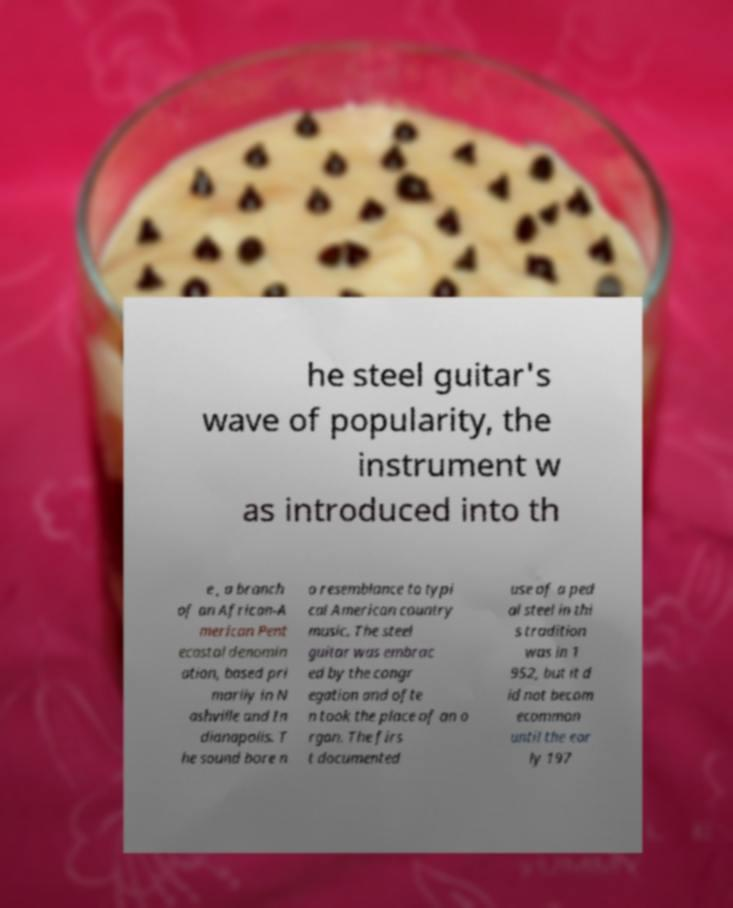Please identify and transcribe the text found in this image. he steel guitar's wave of popularity, the instrument w as introduced into th e , a branch of an African-A merican Pent ecostal denomin ation, based pri marily in N ashville and In dianapolis. T he sound bore n o resemblance to typi cal American country music. The steel guitar was embrac ed by the congr egation and ofte n took the place of an o rgan. The firs t documented use of a ped al steel in thi s tradition was in 1 952, but it d id not becom ecommon until the ear ly 197 